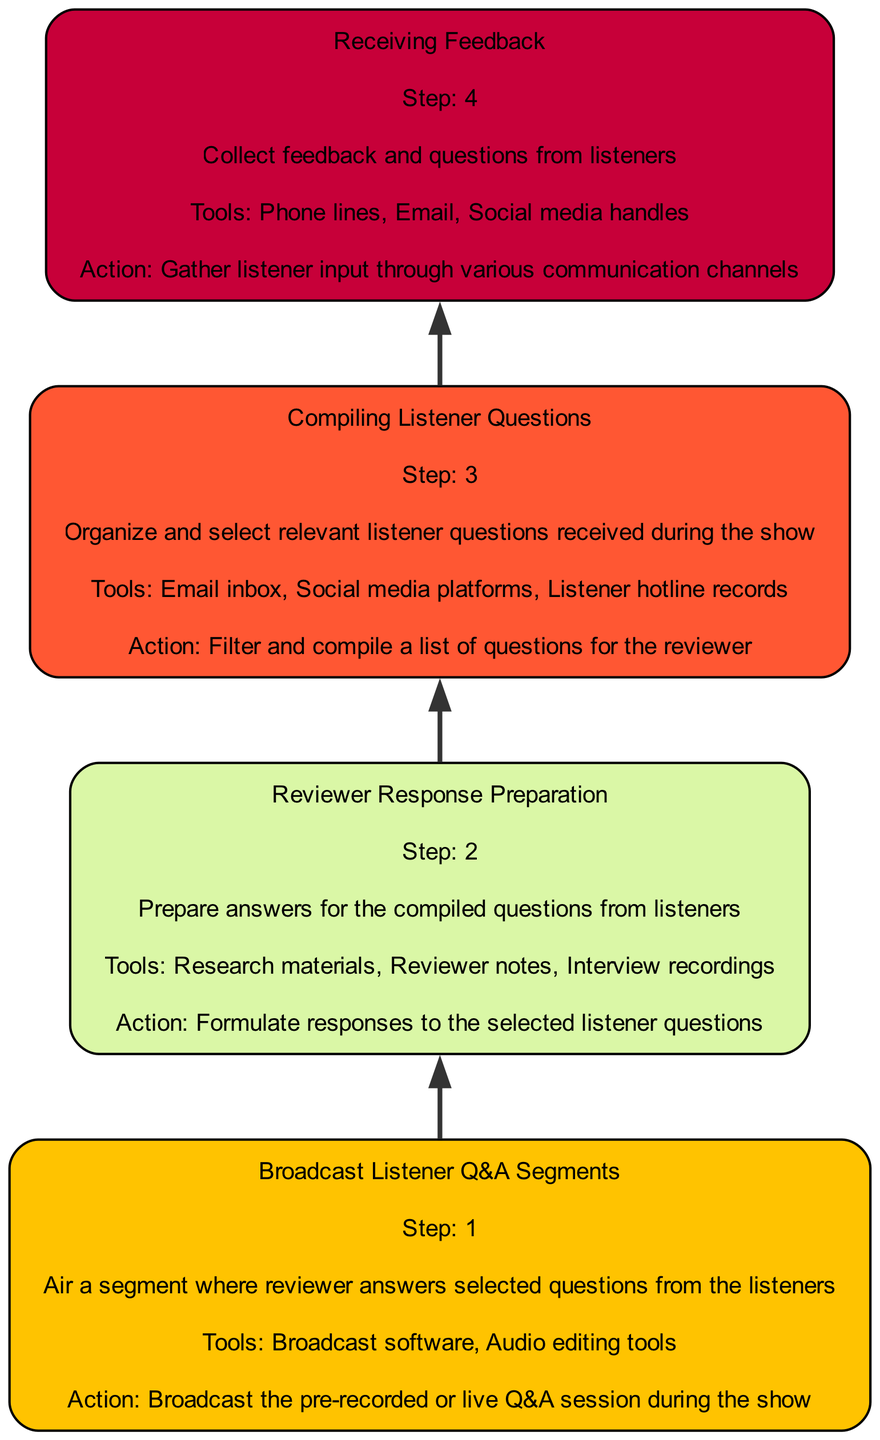What is the first step in the process? The first step in the process, which is indicated at the bottom of the flowchart, is "Receiving Feedback," denoting the beginning of the interaction with listeners.
Answer: Receiving Feedback How many total steps are represented in the diagram? By counting the number of distinct nodes in the flowchart, we see there are four main steps outlined in the process, each representing a specific part of listener interaction.
Answer: 4 What tools are used in "Compiling Listener Questions"? The tools listed for the "Compiling Listener Questions" step include "Email inbox," "Social media platforms," and "Listener hotline records," which are mentioned directly in the node description.
Answer: Email inbox, social media platforms, listener hotline records What action follows after "Receiving Feedback"? Following the "Receiving Feedback" step, the diagram states that the next action is "Compiling Listener Questions," indicating a progression to organize the feedback collected.
Answer: Compiling Listener Questions What is the last step mentioned in the flowchart? The final step in the flowchart is "Broadcast Listener Q&A Segments," which shows the culmination of the entire process where the prepared responses are shared with the audience.
Answer: Broadcast Listener Q&A Segments What is the role of "Reviewer Response Preparation" in the process? "Reviewer Response Preparation" involves formulating responses to the selected listener questions, which is critical for ensuring that the feedback is addressed appropriately before it is broadcasted.
Answer: Formulate responses Which step is directly above "Broadcast Listener Q&A Segments"? The step that is directly above "Broadcast Listener Q&A Segments" in the flowchart is "Reviewer Response Preparation," indicating that the responses are prepared prior to the live or pre-recorded broadcast.
Answer: Reviewer Response Preparation How do listeners provide their feedback? Listeners provide their feedback through multiple channels specified in the "Receiving Feedback" node, including "Phone lines," "Email," and "Social media handles," allowing for diverse input methods.
Answer: Phone lines, email, social media handles What are the main tools used in the final step? The tools referenced in the "Broadcast Listener Q&A Segments" step include "Broadcast software" and "Audio editing tools," which are necessary for the execution of the broadcasting process.
Answer: Broadcast software, audio editing tools 